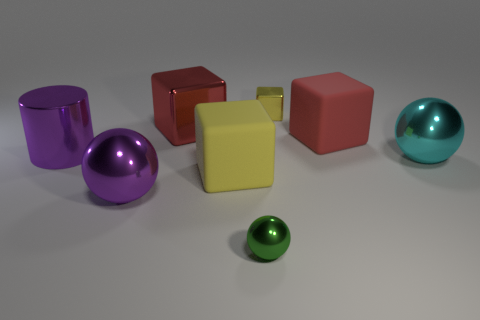Subtract all yellow rubber blocks. How many blocks are left? 3 Subtract all gray cubes. Subtract all blue balls. How many cubes are left? 4 Add 1 big shiny blocks. How many objects exist? 9 Subtract 0 gray cubes. How many objects are left? 8 Subtract all cylinders. How many objects are left? 7 Subtract all blocks. Subtract all large purple objects. How many objects are left? 2 Add 4 large metallic blocks. How many large metallic blocks are left? 5 Add 3 small brown rubber cylinders. How many small brown rubber cylinders exist? 3 